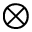Convert formula to latex. <formula><loc_0><loc_0><loc_500><loc_500>\otimes</formula> 